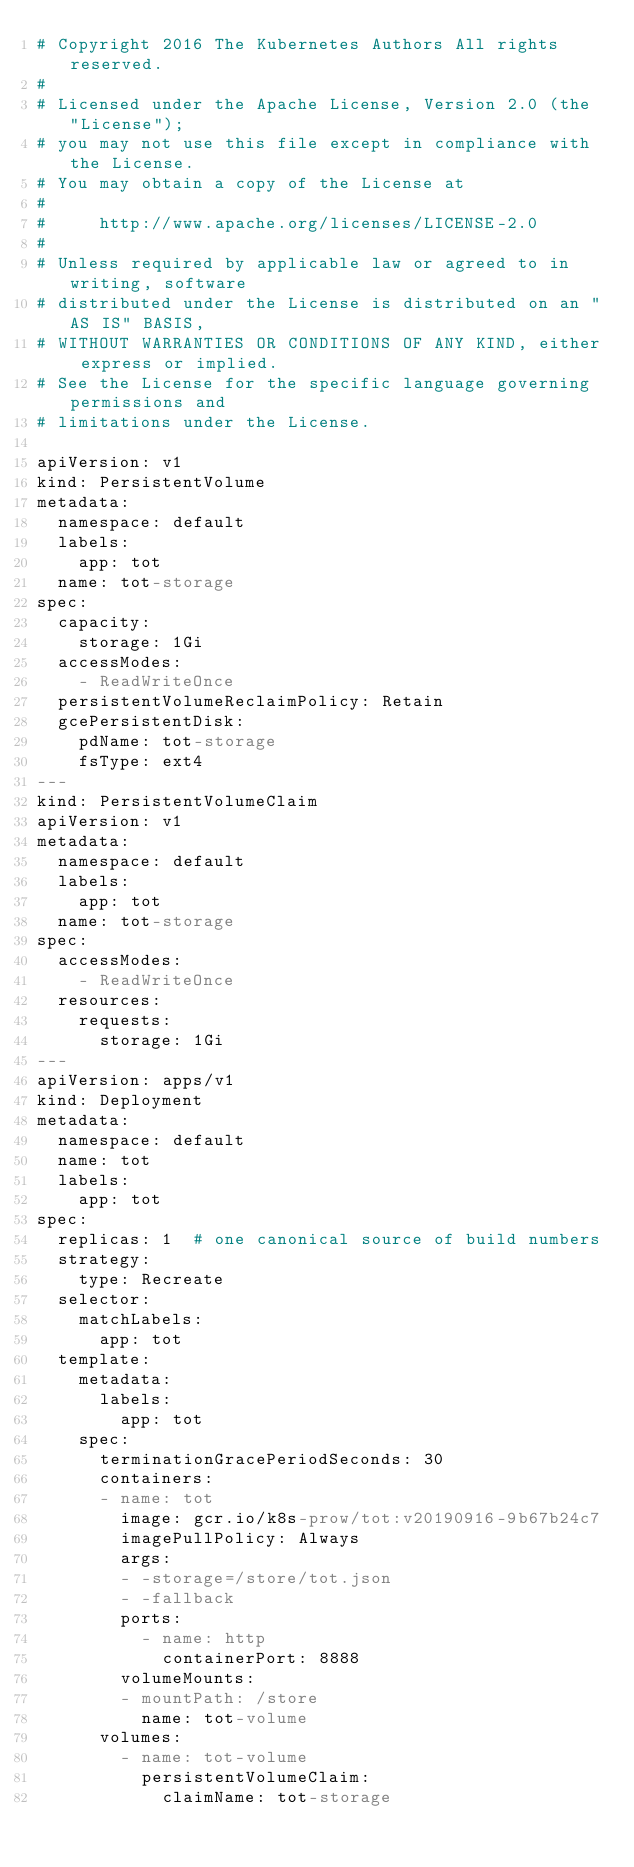<code> <loc_0><loc_0><loc_500><loc_500><_YAML_># Copyright 2016 The Kubernetes Authors All rights reserved.
#
# Licensed under the Apache License, Version 2.0 (the "License");
# you may not use this file except in compliance with the License.
# You may obtain a copy of the License at
#
#     http://www.apache.org/licenses/LICENSE-2.0
#
# Unless required by applicable law or agreed to in writing, software
# distributed under the License is distributed on an "AS IS" BASIS,
# WITHOUT WARRANTIES OR CONDITIONS OF ANY KIND, either express or implied.
# See the License for the specific language governing permissions and
# limitations under the License.

apiVersion: v1
kind: PersistentVolume
metadata:
  namespace: default
  labels:
    app: tot
  name: tot-storage
spec:
  capacity:
    storage: 1Gi
  accessModes:
    - ReadWriteOnce
  persistentVolumeReclaimPolicy: Retain
  gcePersistentDisk:
    pdName: tot-storage
    fsType: ext4
---
kind: PersistentVolumeClaim
apiVersion: v1
metadata:
  namespace: default
  labels:
    app: tot
  name: tot-storage
spec:
  accessModes:
    - ReadWriteOnce
  resources:
    requests:
      storage: 1Gi
---
apiVersion: apps/v1
kind: Deployment
metadata:
  namespace: default
  name: tot
  labels:
    app: tot
spec:
  replicas: 1  # one canonical source of build numbers
  strategy:
    type: Recreate
  selector:
    matchLabels:
      app: tot
  template:
    metadata:
      labels:
        app: tot
    spec:
      terminationGracePeriodSeconds: 30
      containers:
      - name: tot
        image: gcr.io/k8s-prow/tot:v20190916-9b67b24c7
        imagePullPolicy: Always
        args:
        - -storage=/store/tot.json
        - -fallback
        ports:
          - name: http
            containerPort: 8888
        volumeMounts:
        - mountPath: /store
          name: tot-volume
      volumes:
        - name: tot-volume
          persistentVolumeClaim:
            claimName: tot-storage
</code> 